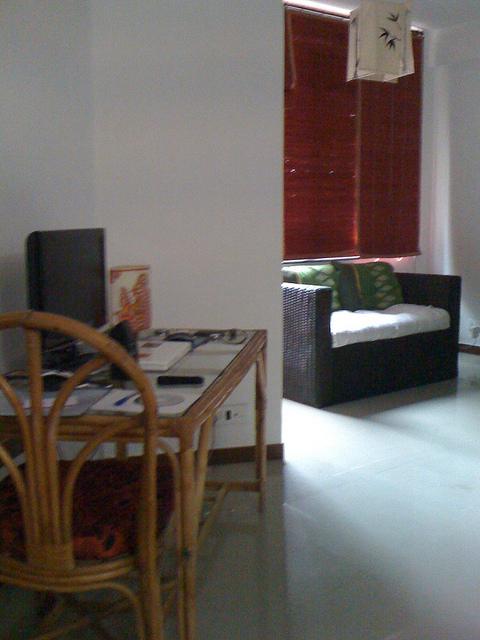How many objects are on the small table?
Concise answer only. 10. What color are the curtains?
Keep it brief. Red. Is there vases here?
Short answer required. No. Is the tv on?
Write a very short answer. No. 